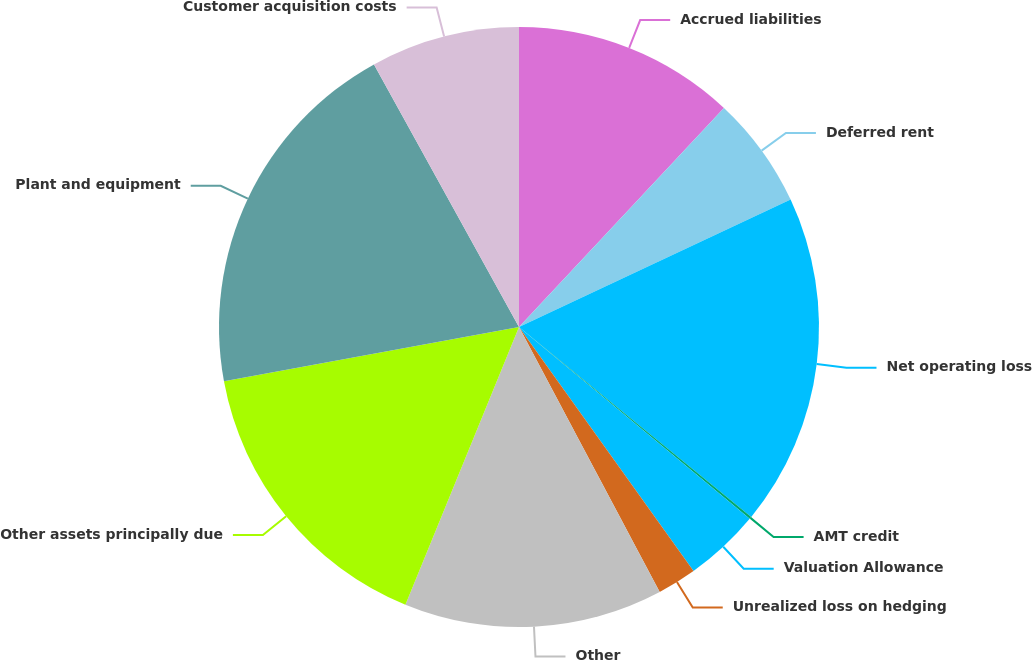Convert chart. <chart><loc_0><loc_0><loc_500><loc_500><pie_chart><fcel>Accrued liabilities<fcel>Deferred rent<fcel>Net operating loss<fcel>AMT credit<fcel>Valuation Allowance<fcel>Unrealized loss on hedging<fcel>Other<fcel>Other assets principally due<fcel>Plant and equipment<fcel>Customer acquisition costs<nl><fcel>11.97%<fcel>6.05%<fcel>17.89%<fcel>0.13%<fcel>4.08%<fcel>2.11%<fcel>13.95%<fcel>15.92%<fcel>19.87%<fcel>8.03%<nl></chart> 